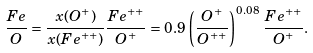<formula> <loc_0><loc_0><loc_500><loc_500>\frac { F e } { O } = \frac { x ( O ^ { + } ) } { x ( F e ^ { + + } ) } \frac { F e ^ { + + } } { O ^ { + } } = 0 . 9 \, \left ( \frac { O ^ { + } } { O ^ { + + } } \right ) ^ { 0 . 0 8 } \, \frac { F e ^ { + + } } { O ^ { + } } .</formula> 